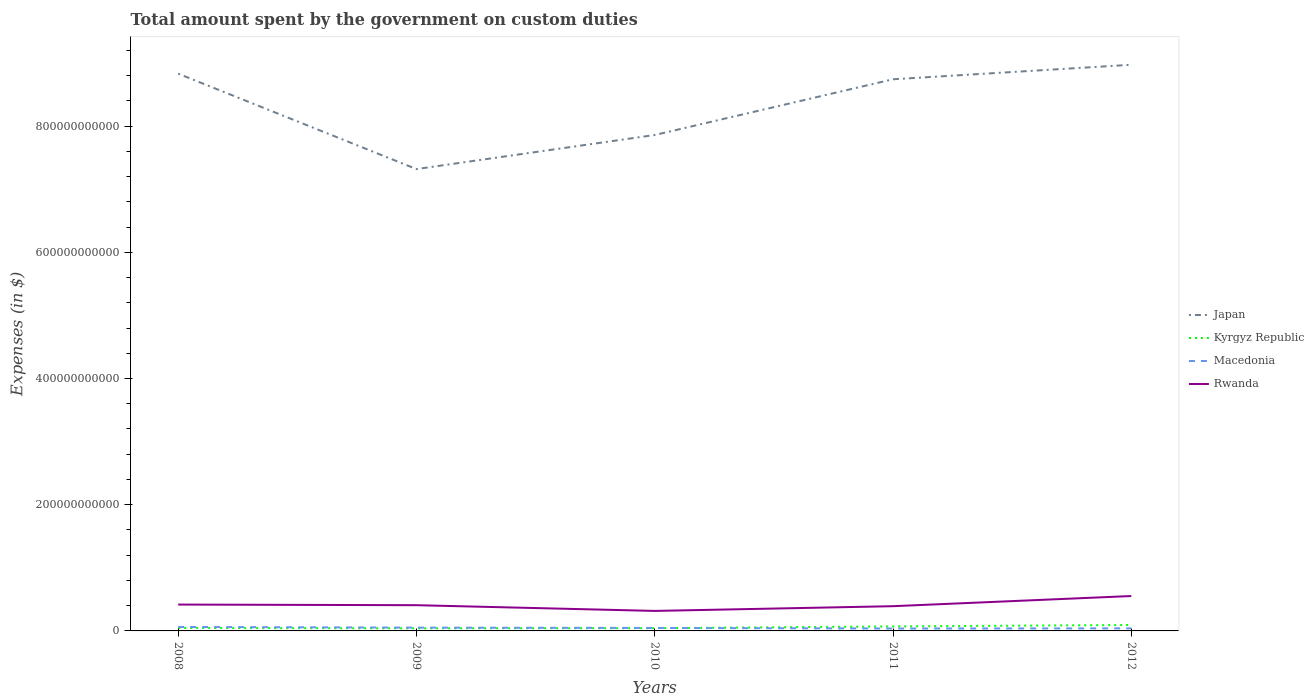How many different coloured lines are there?
Give a very brief answer. 4. Does the line corresponding to Japan intersect with the line corresponding to Kyrgyz Republic?
Your response must be concise. No. Is the number of lines equal to the number of legend labels?
Provide a short and direct response. Yes. Across all years, what is the maximum amount spent on custom duties by the government in Kyrgyz Republic?
Ensure brevity in your answer.  4.14e+09. In which year was the amount spent on custom duties by the government in Japan maximum?
Keep it short and to the point. 2009. What is the total amount spent on custom duties by the government in Rwanda in the graph?
Provide a short and direct response. 9.08e+09. What is the difference between the highest and the second highest amount spent on custom duties by the government in Japan?
Offer a very short reply. 1.65e+11. Is the amount spent on custom duties by the government in Japan strictly greater than the amount spent on custom duties by the government in Rwanda over the years?
Keep it short and to the point. No. How many lines are there?
Give a very brief answer. 4. What is the difference between two consecutive major ticks on the Y-axis?
Provide a short and direct response. 2.00e+11. Are the values on the major ticks of Y-axis written in scientific E-notation?
Provide a succinct answer. No. Does the graph contain any zero values?
Make the answer very short. No. How many legend labels are there?
Give a very brief answer. 4. How are the legend labels stacked?
Ensure brevity in your answer.  Vertical. What is the title of the graph?
Keep it short and to the point. Total amount spent by the government on custom duties. Does "Marshall Islands" appear as one of the legend labels in the graph?
Offer a terse response. No. What is the label or title of the Y-axis?
Your answer should be very brief. Expenses (in $). What is the Expenses (in $) of Japan in 2008?
Offer a terse response. 8.83e+11. What is the Expenses (in $) in Kyrgyz Republic in 2008?
Keep it short and to the point. 4.63e+09. What is the Expenses (in $) in Macedonia in 2008?
Your answer should be compact. 6.28e+09. What is the Expenses (in $) of Rwanda in 2008?
Keep it short and to the point. 4.18e+1. What is the Expenses (in $) in Japan in 2009?
Your answer should be compact. 7.32e+11. What is the Expenses (in $) in Kyrgyz Republic in 2009?
Give a very brief answer. 4.14e+09. What is the Expenses (in $) in Macedonia in 2009?
Provide a short and direct response. 5.23e+09. What is the Expenses (in $) in Rwanda in 2009?
Make the answer very short. 4.08e+1. What is the Expenses (in $) of Japan in 2010?
Keep it short and to the point. 7.86e+11. What is the Expenses (in $) of Kyrgyz Republic in 2010?
Offer a very short reply. 4.34e+09. What is the Expenses (in $) in Macedonia in 2010?
Offer a terse response. 4.71e+09. What is the Expenses (in $) in Rwanda in 2010?
Make the answer very short. 3.17e+1. What is the Expenses (in $) in Japan in 2011?
Your answer should be very brief. 8.74e+11. What is the Expenses (in $) of Kyrgyz Republic in 2011?
Provide a succinct answer. 7.15e+09. What is the Expenses (in $) of Macedonia in 2011?
Your answer should be compact. 3.78e+09. What is the Expenses (in $) of Rwanda in 2011?
Keep it short and to the point. 3.92e+1. What is the Expenses (in $) in Japan in 2012?
Provide a succinct answer. 8.97e+11. What is the Expenses (in $) in Kyrgyz Republic in 2012?
Make the answer very short. 9.43e+09. What is the Expenses (in $) in Macedonia in 2012?
Offer a very short reply. 4.07e+09. What is the Expenses (in $) in Rwanda in 2012?
Offer a terse response. 5.53e+1. Across all years, what is the maximum Expenses (in $) in Japan?
Offer a terse response. 8.97e+11. Across all years, what is the maximum Expenses (in $) in Kyrgyz Republic?
Make the answer very short. 9.43e+09. Across all years, what is the maximum Expenses (in $) in Macedonia?
Provide a short and direct response. 6.28e+09. Across all years, what is the maximum Expenses (in $) of Rwanda?
Provide a succinct answer. 5.53e+1. Across all years, what is the minimum Expenses (in $) of Japan?
Your answer should be very brief. 7.32e+11. Across all years, what is the minimum Expenses (in $) of Kyrgyz Republic?
Offer a very short reply. 4.14e+09. Across all years, what is the minimum Expenses (in $) in Macedonia?
Make the answer very short. 3.78e+09. Across all years, what is the minimum Expenses (in $) of Rwanda?
Give a very brief answer. 3.17e+1. What is the total Expenses (in $) of Japan in the graph?
Make the answer very short. 4.17e+12. What is the total Expenses (in $) of Kyrgyz Republic in the graph?
Your answer should be compact. 2.97e+1. What is the total Expenses (in $) in Macedonia in the graph?
Keep it short and to the point. 2.41e+1. What is the total Expenses (in $) of Rwanda in the graph?
Give a very brief answer. 2.09e+11. What is the difference between the Expenses (in $) of Japan in 2008 and that in 2009?
Your response must be concise. 1.51e+11. What is the difference between the Expenses (in $) in Kyrgyz Republic in 2008 and that in 2009?
Provide a short and direct response. 4.96e+08. What is the difference between the Expenses (in $) in Macedonia in 2008 and that in 2009?
Make the answer very short. 1.05e+09. What is the difference between the Expenses (in $) in Rwanda in 2008 and that in 2009?
Provide a short and direct response. 9.98e+08. What is the difference between the Expenses (in $) of Japan in 2008 and that in 2010?
Make the answer very short. 9.72e+1. What is the difference between the Expenses (in $) of Kyrgyz Republic in 2008 and that in 2010?
Ensure brevity in your answer.  2.90e+08. What is the difference between the Expenses (in $) in Macedonia in 2008 and that in 2010?
Provide a short and direct response. 1.56e+09. What is the difference between the Expenses (in $) in Rwanda in 2008 and that in 2010?
Ensure brevity in your answer.  1.01e+1. What is the difference between the Expenses (in $) of Japan in 2008 and that in 2011?
Your response must be concise. 8.90e+09. What is the difference between the Expenses (in $) in Kyrgyz Republic in 2008 and that in 2011?
Your response must be concise. -2.52e+09. What is the difference between the Expenses (in $) in Macedonia in 2008 and that in 2011?
Keep it short and to the point. 2.50e+09. What is the difference between the Expenses (in $) in Rwanda in 2008 and that in 2011?
Provide a short and direct response. 2.58e+09. What is the difference between the Expenses (in $) of Japan in 2008 and that in 2012?
Provide a succinct answer. -1.41e+1. What is the difference between the Expenses (in $) in Kyrgyz Republic in 2008 and that in 2012?
Your response must be concise. -4.80e+09. What is the difference between the Expenses (in $) of Macedonia in 2008 and that in 2012?
Give a very brief answer. 2.21e+09. What is the difference between the Expenses (in $) in Rwanda in 2008 and that in 2012?
Provide a succinct answer. -1.35e+1. What is the difference between the Expenses (in $) of Japan in 2009 and that in 2010?
Ensure brevity in your answer.  -5.40e+1. What is the difference between the Expenses (in $) in Kyrgyz Republic in 2009 and that in 2010?
Your answer should be very brief. -2.06e+08. What is the difference between the Expenses (in $) of Macedonia in 2009 and that in 2010?
Ensure brevity in your answer.  5.17e+08. What is the difference between the Expenses (in $) in Rwanda in 2009 and that in 2010?
Provide a short and direct response. 9.08e+09. What is the difference between the Expenses (in $) in Japan in 2009 and that in 2011?
Make the answer very short. -1.42e+11. What is the difference between the Expenses (in $) in Kyrgyz Republic in 2009 and that in 2011?
Keep it short and to the point. -3.01e+09. What is the difference between the Expenses (in $) in Macedonia in 2009 and that in 2011?
Ensure brevity in your answer.  1.45e+09. What is the difference between the Expenses (in $) in Rwanda in 2009 and that in 2011?
Offer a terse response. 1.58e+09. What is the difference between the Expenses (in $) in Japan in 2009 and that in 2012?
Keep it short and to the point. -1.65e+11. What is the difference between the Expenses (in $) of Kyrgyz Republic in 2009 and that in 2012?
Ensure brevity in your answer.  -5.29e+09. What is the difference between the Expenses (in $) of Macedonia in 2009 and that in 2012?
Keep it short and to the point. 1.16e+09. What is the difference between the Expenses (in $) in Rwanda in 2009 and that in 2012?
Your answer should be very brief. -1.45e+1. What is the difference between the Expenses (in $) in Japan in 2010 and that in 2011?
Offer a very short reply. -8.83e+1. What is the difference between the Expenses (in $) of Kyrgyz Republic in 2010 and that in 2011?
Your answer should be compact. -2.81e+09. What is the difference between the Expenses (in $) of Macedonia in 2010 and that in 2011?
Your answer should be compact. 9.33e+08. What is the difference between the Expenses (in $) of Rwanda in 2010 and that in 2011?
Provide a succinct answer. -7.50e+09. What is the difference between the Expenses (in $) in Japan in 2010 and that in 2012?
Keep it short and to the point. -1.11e+11. What is the difference between the Expenses (in $) in Kyrgyz Republic in 2010 and that in 2012?
Offer a terse response. -5.09e+09. What is the difference between the Expenses (in $) in Macedonia in 2010 and that in 2012?
Give a very brief answer. 6.45e+08. What is the difference between the Expenses (in $) in Rwanda in 2010 and that in 2012?
Make the answer very short. -2.36e+1. What is the difference between the Expenses (in $) in Japan in 2011 and that in 2012?
Ensure brevity in your answer.  -2.30e+1. What is the difference between the Expenses (in $) of Kyrgyz Republic in 2011 and that in 2012?
Your answer should be very brief. -2.28e+09. What is the difference between the Expenses (in $) in Macedonia in 2011 and that in 2012?
Your answer should be compact. -2.88e+08. What is the difference between the Expenses (in $) in Rwanda in 2011 and that in 2012?
Make the answer very short. -1.61e+1. What is the difference between the Expenses (in $) in Japan in 2008 and the Expenses (in $) in Kyrgyz Republic in 2009?
Offer a terse response. 8.79e+11. What is the difference between the Expenses (in $) of Japan in 2008 and the Expenses (in $) of Macedonia in 2009?
Your response must be concise. 8.78e+11. What is the difference between the Expenses (in $) in Japan in 2008 and the Expenses (in $) in Rwanda in 2009?
Your response must be concise. 8.42e+11. What is the difference between the Expenses (in $) in Kyrgyz Republic in 2008 and the Expenses (in $) in Macedonia in 2009?
Your answer should be very brief. -5.97e+08. What is the difference between the Expenses (in $) of Kyrgyz Republic in 2008 and the Expenses (in $) of Rwanda in 2009?
Ensure brevity in your answer.  -3.61e+1. What is the difference between the Expenses (in $) in Macedonia in 2008 and the Expenses (in $) in Rwanda in 2009?
Provide a succinct answer. -3.45e+1. What is the difference between the Expenses (in $) of Japan in 2008 and the Expenses (in $) of Kyrgyz Republic in 2010?
Provide a succinct answer. 8.79e+11. What is the difference between the Expenses (in $) in Japan in 2008 and the Expenses (in $) in Macedonia in 2010?
Your response must be concise. 8.78e+11. What is the difference between the Expenses (in $) of Japan in 2008 and the Expenses (in $) of Rwanda in 2010?
Provide a succinct answer. 8.51e+11. What is the difference between the Expenses (in $) of Kyrgyz Republic in 2008 and the Expenses (in $) of Macedonia in 2010?
Offer a terse response. -8.02e+07. What is the difference between the Expenses (in $) in Kyrgyz Republic in 2008 and the Expenses (in $) in Rwanda in 2010?
Provide a succinct answer. -2.71e+1. What is the difference between the Expenses (in $) in Macedonia in 2008 and the Expenses (in $) in Rwanda in 2010?
Your response must be concise. -2.54e+1. What is the difference between the Expenses (in $) in Japan in 2008 and the Expenses (in $) in Kyrgyz Republic in 2011?
Provide a succinct answer. 8.76e+11. What is the difference between the Expenses (in $) of Japan in 2008 and the Expenses (in $) of Macedonia in 2011?
Give a very brief answer. 8.79e+11. What is the difference between the Expenses (in $) of Japan in 2008 and the Expenses (in $) of Rwanda in 2011?
Keep it short and to the point. 8.44e+11. What is the difference between the Expenses (in $) in Kyrgyz Republic in 2008 and the Expenses (in $) in Macedonia in 2011?
Keep it short and to the point. 8.53e+08. What is the difference between the Expenses (in $) of Kyrgyz Republic in 2008 and the Expenses (in $) of Rwanda in 2011?
Provide a short and direct response. -3.46e+1. What is the difference between the Expenses (in $) of Macedonia in 2008 and the Expenses (in $) of Rwanda in 2011?
Your response must be concise. -3.29e+1. What is the difference between the Expenses (in $) of Japan in 2008 and the Expenses (in $) of Kyrgyz Republic in 2012?
Your answer should be very brief. 8.74e+11. What is the difference between the Expenses (in $) of Japan in 2008 and the Expenses (in $) of Macedonia in 2012?
Ensure brevity in your answer.  8.79e+11. What is the difference between the Expenses (in $) in Japan in 2008 and the Expenses (in $) in Rwanda in 2012?
Keep it short and to the point. 8.28e+11. What is the difference between the Expenses (in $) of Kyrgyz Republic in 2008 and the Expenses (in $) of Macedonia in 2012?
Give a very brief answer. 5.65e+08. What is the difference between the Expenses (in $) of Kyrgyz Republic in 2008 and the Expenses (in $) of Rwanda in 2012?
Your answer should be compact. -5.07e+1. What is the difference between the Expenses (in $) of Macedonia in 2008 and the Expenses (in $) of Rwanda in 2012?
Offer a terse response. -4.90e+1. What is the difference between the Expenses (in $) of Japan in 2009 and the Expenses (in $) of Kyrgyz Republic in 2010?
Offer a very short reply. 7.28e+11. What is the difference between the Expenses (in $) in Japan in 2009 and the Expenses (in $) in Macedonia in 2010?
Give a very brief answer. 7.27e+11. What is the difference between the Expenses (in $) of Japan in 2009 and the Expenses (in $) of Rwanda in 2010?
Offer a terse response. 7.00e+11. What is the difference between the Expenses (in $) in Kyrgyz Republic in 2009 and the Expenses (in $) in Macedonia in 2010?
Ensure brevity in your answer.  -5.77e+08. What is the difference between the Expenses (in $) of Kyrgyz Republic in 2009 and the Expenses (in $) of Rwanda in 2010?
Make the answer very short. -2.76e+1. What is the difference between the Expenses (in $) of Macedonia in 2009 and the Expenses (in $) of Rwanda in 2010?
Offer a very short reply. -2.65e+1. What is the difference between the Expenses (in $) of Japan in 2009 and the Expenses (in $) of Kyrgyz Republic in 2011?
Your answer should be compact. 7.25e+11. What is the difference between the Expenses (in $) of Japan in 2009 and the Expenses (in $) of Macedonia in 2011?
Your response must be concise. 7.28e+11. What is the difference between the Expenses (in $) of Japan in 2009 and the Expenses (in $) of Rwanda in 2011?
Make the answer very short. 6.93e+11. What is the difference between the Expenses (in $) of Kyrgyz Republic in 2009 and the Expenses (in $) of Macedonia in 2011?
Your answer should be very brief. 3.56e+08. What is the difference between the Expenses (in $) of Kyrgyz Republic in 2009 and the Expenses (in $) of Rwanda in 2011?
Your answer should be compact. -3.51e+1. What is the difference between the Expenses (in $) in Macedonia in 2009 and the Expenses (in $) in Rwanda in 2011?
Your answer should be compact. -3.40e+1. What is the difference between the Expenses (in $) in Japan in 2009 and the Expenses (in $) in Kyrgyz Republic in 2012?
Make the answer very short. 7.22e+11. What is the difference between the Expenses (in $) of Japan in 2009 and the Expenses (in $) of Macedonia in 2012?
Ensure brevity in your answer.  7.28e+11. What is the difference between the Expenses (in $) of Japan in 2009 and the Expenses (in $) of Rwanda in 2012?
Give a very brief answer. 6.77e+11. What is the difference between the Expenses (in $) in Kyrgyz Republic in 2009 and the Expenses (in $) in Macedonia in 2012?
Your answer should be very brief. 6.84e+07. What is the difference between the Expenses (in $) in Kyrgyz Republic in 2009 and the Expenses (in $) in Rwanda in 2012?
Provide a succinct answer. -5.12e+1. What is the difference between the Expenses (in $) in Macedonia in 2009 and the Expenses (in $) in Rwanda in 2012?
Give a very brief answer. -5.01e+1. What is the difference between the Expenses (in $) in Japan in 2010 and the Expenses (in $) in Kyrgyz Republic in 2011?
Provide a succinct answer. 7.79e+11. What is the difference between the Expenses (in $) in Japan in 2010 and the Expenses (in $) in Macedonia in 2011?
Provide a succinct answer. 7.82e+11. What is the difference between the Expenses (in $) in Japan in 2010 and the Expenses (in $) in Rwanda in 2011?
Offer a very short reply. 7.47e+11. What is the difference between the Expenses (in $) of Kyrgyz Republic in 2010 and the Expenses (in $) of Macedonia in 2011?
Your answer should be compact. 5.63e+08. What is the difference between the Expenses (in $) in Kyrgyz Republic in 2010 and the Expenses (in $) in Rwanda in 2011?
Provide a succinct answer. -3.49e+1. What is the difference between the Expenses (in $) of Macedonia in 2010 and the Expenses (in $) of Rwanda in 2011?
Provide a short and direct response. -3.45e+1. What is the difference between the Expenses (in $) of Japan in 2010 and the Expenses (in $) of Kyrgyz Republic in 2012?
Your answer should be compact. 7.76e+11. What is the difference between the Expenses (in $) of Japan in 2010 and the Expenses (in $) of Macedonia in 2012?
Your answer should be very brief. 7.82e+11. What is the difference between the Expenses (in $) of Japan in 2010 and the Expenses (in $) of Rwanda in 2012?
Keep it short and to the point. 7.31e+11. What is the difference between the Expenses (in $) in Kyrgyz Republic in 2010 and the Expenses (in $) in Macedonia in 2012?
Your answer should be very brief. 2.75e+08. What is the difference between the Expenses (in $) in Kyrgyz Republic in 2010 and the Expenses (in $) in Rwanda in 2012?
Provide a short and direct response. -5.10e+1. What is the difference between the Expenses (in $) of Macedonia in 2010 and the Expenses (in $) of Rwanda in 2012?
Provide a succinct answer. -5.06e+1. What is the difference between the Expenses (in $) of Japan in 2011 and the Expenses (in $) of Kyrgyz Republic in 2012?
Provide a short and direct response. 8.65e+11. What is the difference between the Expenses (in $) in Japan in 2011 and the Expenses (in $) in Macedonia in 2012?
Keep it short and to the point. 8.70e+11. What is the difference between the Expenses (in $) of Japan in 2011 and the Expenses (in $) of Rwanda in 2012?
Keep it short and to the point. 8.19e+11. What is the difference between the Expenses (in $) of Kyrgyz Republic in 2011 and the Expenses (in $) of Macedonia in 2012?
Give a very brief answer. 3.08e+09. What is the difference between the Expenses (in $) in Kyrgyz Republic in 2011 and the Expenses (in $) in Rwanda in 2012?
Keep it short and to the point. -4.82e+1. What is the difference between the Expenses (in $) of Macedonia in 2011 and the Expenses (in $) of Rwanda in 2012?
Give a very brief answer. -5.15e+1. What is the average Expenses (in $) of Japan per year?
Provide a short and direct response. 8.34e+11. What is the average Expenses (in $) of Kyrgyz Republic per year?
Your answer should be compact. 5.94e+09. What is the average Expenses (in $) of Macedonia per year?
Offer a terse response. 4.81e+09. What is the average Expenses (in $) of Rwanda per year?
Offer a terse response. 4.18e+1. In the year 2008, what is the difference between the Expenses (in $) in Japan and Expenses (in $) in Kyrgyz Republic?
Provide a succinct answer. 8.78e+11. In the year 2008, what is the difference between the Expenses (in $) in Japan and Expenses (in $) in Macedonia?
Make the answer very short. 8.77e+11. In the year 2008, what is the difference between the Expenses (in $) in Japan and Expenses (in $) in Rwanda?
Make the answer very short. 8.41e+11. In the year 2008, what is the difference between the Expenses (in $) of Kyrgyz Republic and Expenses (in $) of Macedonia?
Keep it short and to the point. -1.64e+09. In the year 2008, what is the difference between the Expenses (in $) of Kyrgyz Republic and Expenses (in $) of Rwanda?
Offer a terse response. -3.71e+1. In the year 2008, what is the difference between the Expenses (in $) of Macedonia and Expenses (in $) of Rwanda?
Offer a terse response. -3.55e+1. In the year 2009, what is the difference between the Expenses (in $) in Japan and Expenses (in $) in Kyrgyz Republic?
Offer a very short reply. 7.28e+11. In the year 2009, what is the difference between the Expenses (in $) in Japan and Expenses (in $) in Macedonia?
Your answer should be compact. 7.27e+11. In the year 2009, what is the difference between the Expenses (in $) of Japan and Expenses (in $) of Rwanda?
Provide a short and direct response. 6.91e+11. In the year 2009, what is the difference between the Expenses (in $) in Kyrgyz Republic and Expenses (in $) in Macedonia?
Ensure brevity in your answer.  -1.09e+09. In the year 2009, what is the difference between the Expenses (in $) of Kyrgyz Republic and Expenses (in $) of Rwanda?
Offer a very short reply. -3.66e+1. In the year 2009, what is the difference between the Expenses (in $) of Macedonia and Expenses (in $) of Rwanda?
Keep it short and to the point. -3.56e+1. In the year 2010, what is the difference between the Expenses (in $) in Japan and Expenses (in $) in Kyrgyz Republic?
Make the answer very short. 7.82e+11. In the year 2010, what is the difference between the Expenses (in $) of Japan and Expenses (in $) of Macedonia?
Your answer should be very brief. 7.81e+11. In the year 2010, what is the difference between the Expenses (in $) of Japan and Expenses (in $) of Rwanda?
Give a very brief answer. 7.54e+11. In the year 2010, what is the difference between the Expenses (in $) in Kyrgyz Republic and Expenses (in $) in Macedonia?
Provide a succinct answer. -3.70e+08. In the year 2010, what is the difference between the Expenses (in $) in Kyrgyz Republic and Expenses (in $) in Rwanda?
Keep it short and to the point. -2.74e+1. In the year 2010, what is the difference between the Expenses (in $) of Macedonia and Expenses (in $) of Rwanda?
Give a very brief answer. -2.70e+1. In the year 2011, what is the difference between the Expenses (in $) in Japan and Expenses (in $) in Kyrgyz Republic?
Keep it short and to the point. 8.67e+11. In the year 2011, what is the difference between the Expenses (in $) in Japan and Expenses (in $) in Macedonia?
Make the answer very short. 8.70e+11. In the year 2011, what is the difference between the Expenses (in $) of Japan and Expenses (in $) of Rwanda?
Keep it short and to the point. 8.35e+11. In the year 2011, what is the difference between the Expenses (in $) of Kyrgyz Republic and Expenses (in $) of Macedonia?
Make the answer very short. 3.37e+09. In the year 2011, what is the difference between the Expenses (in $) of Kyrgyz Republic and Expenses (in $) of Rwanda?
Offer a very short reply. -3.21e+1. In the year 2011, what is the difference between the Expenses (in $) in Macedonia and Expenses (in $) in Rwanda?
Offer a very short reply. -3.54e+1. In the year 2012, what is the difference between the Expenses (in $) of Japan and Expenses (in $) of Kyrgyz Republic?
Your response must be concise. 8.88e+11. In the year 2012, what is the difference between the Expenses (in $) in Japan and Expenses (in $) in Macedonia?
Give a very brief answer. 8.93e+11. In the year 2012, what is the difference between the Expenses (in $) in Japan and Expenses (in $) in Rwanda?
Provide a short and direct response. 8.42e+11. In the year 2012, what is the difference between the Expenses (in $) in Kyrgyz Republic and Expenses (in $) in Macedonia?
Make the answer very short. 5.36e+09. In the year 2012, what is the difference between the Expenses (in $) in Kyrgyz Republic and Expenses (in $) in Rwanda?
Make the answer very short. -4.59e+1. In the year 2012, what is the difference between the Expenses (in $) in Macedonia and Expenses (in $) in Rwanda?
Your answer should be very brief. -5.12e+1. What is the ratio of the Expenses (in $) of Japan in 2008 to that in 2009?
Your response must be concise. 1.21. What is the ratio of the Expenses (in $) of Kyrgyz Republic in 2008 to that in 2009?
Keep it short and to the point. 1.12. What is the ratio of the Expenses (in $) of Macedonia in 2008 to that in 2009?
Provide a succinct answer. 1.2. What is the ratio of the Expenses (in $) of Rwanda in 2008 to that in 2009?
Offer a very short reply. 1.02. What is the ratio of the Expenses (in $) of Japan in 2008 to that in 2010?
Provide a short and direct response. 1.12. What is the ratio of the Expenses (in $) in Kyrgyz Republic in 2008 to that in 2010?
Make the answer very short. 1.07. What is the ratio of the Expenses (in $) in Macedonia in 2008 to that in 2010?
Provide a short and direct response. 1.33. What is the ratio of the Expenses (in $) in Rwanda in 2008 to that in 2010?
Keep it short and to the point. 1.32. What is the ratio of the Expenses (in $) in Japan in 2008 to that in 2011?
Make the answer very short. 1.01. What is the ratio of the Expenses (in $) in Kyrgyz Republic in 2008 to that in 2011?
Ensure brevity in your answer.  0.65. What is the ratio of the Expenses (in $) of Macedonia in 2008 to that in 2011?
Offer a very short reply. 1.66. What is the ratio of the Expenses (in $) of Rwanda in 2008 to that in 2011?
Offer a terse response. 1.07. What is the ratio of the Expenses (in $) of Japan in 2008 to that in 2012?
Your answer should be very brief. 0.98. What is the ratio of the Expenses (in $) in Kyrgyz Republic in 2008 to that in 2012?
Provide a short and direct response. 0.49. What is the ratio of the Expenses (in $) of Macedonia in 2008 to that in 2012?
Your answer should be very brief. 1.54. What is the ratio of the Expenses (in $) of Rwanda in 2008 to that in 2012?
Offer a terse response. 0.76. What is the ratio of the Expenses (in $) in Japan in 2009 to that in 2010?
Provide a short and direct response. 0.93. What is the ratio of the Expenses (in $) in Kyrgyz Republic in 2009 to that in 2010?
Your answer should be compact. 0.95. What is the ratio of the Expenses (in $) in Macedonia in 2009 to that in 2010?
Keep it short and to the point. 1.11. What is the ratio of the Expenses (in $) of Rwanda in 2009 to that in 2010?
Provide a short and direct response. 1.29. What is the ratio of the Expenses (in $) in Japan in 2009 to that in 2011?
Offer a very short reply. 0.84. What is the ratio of the Expenses (in $) of Kyrgyz Republic in 2009 to that in 2011?
Your answer should be very brief. 0.58. What is the ratio of the Expenses (in $) in Macedonia in 2009 to that in 2011?
Offer a very short reply. 1.38. What is the ratio of the Expenses (in $) in Rwanda in 2009 to that in 2011?
Provide a succinct answer. 1.04. What is the ratio of the Expenses (in $) in Japan in 2009 to that in 2012?
Provide a short and direct response. 0.82. What is the ratio of the Expenses (in $) of Kyrgyz Republic in 2009 to that in 2012?
Provide a short and direct response. 0.44. What is the ratio of the Expenses (in $) in Macedonia in 2009 to that in 2012?
Keep it short and to the point. 1.29. What is the ratio of the Expenses (in $) in Rwanda in 2009 to that in 2012?
Your response must be concise. 0.74. What is the ratio of the Expenses (in $) in Japan in 2010 to that in 2011?
Ensure brevity in your answer.  0.9. What is the ratio of the Expenses (in $) in Kyrgyz Republic in 2010 to that in 2011?
Keep it short and to the point. 0.61. What is the ratio of the Expenses (in $) in Macedonia in 2010 to that in 2011?
Keep it short and to the point. 1.25. What is the ratio of the Expenses (in $) of Rwanda in 2010 to that in 2011?
Make the answer very short. 0.81. What is the ratio of the Expenses (in $) in Japan in 2010 to that in 2012?
Ensure brevity in your answer.  0.88. What is the ratio of the Expenses (in $) in Kyrgyz Republic in 2010 to that in 2012?
Provide a succinct answer. 0.46. What is the ratio of the Expenses (in $) of Macedonia in 2010 to that in 2012?
Your response must be concise. 1.16. What is the ratio of the Expenses (in $) of Rwanda in 2010 to that in 2012?
Ensure brevity in your answer.  0.57. What is the ratio of the Expenses (in $) of Japan in 2011 to that in 2012?
Keep it short and to the point. 0.97. What is the ratio of the Expenses (in $) of Kyrgyz Republic in 2011 to that in 2012?
Your answer should be very brief. 0.76. What is the ratio of the Expenses (in $) in Macedonia in 2011 to that in 2012?
Your answer should be compact. 0.93. What is the ratio of the Expenses (in $) of Rwanda in 2011 to that in 2012?
Your response must be concise. 0.71. What is the difference between the highest and the second highest Expenses (in $) of Japan?
Your response must be concise. 1.41e+1. What is the difference between the highest and the second highest Expenses (in $) in Kyrgyz Republic?
Your answer should be very brief. 2.28e+09. What is the difference between the highest and the second highest Expenses (in $) in Macedonia?
Offer a very short reply. 1.05e+09. What is the difference between the highest and the second highest Expenses (in $) in Rwanda?
Provide a short and direct response. 1.35e+1. What is the difference between the highest and the lowest Expenses (in $) in Japan?
Provide a short and direct response. 1.65e+11. What is the difference between the highest and the lowest Expenses (in $) of Kyrgyz Republic?
Ensure brevity in your answer.  5.29e+09. What is the difference between the highest and the lowest Expenses (in $) in Macedonia?
Provide a succinct answer. 2.50e+09. What is the difference between the highest and the lowest Expenses (in $) of Rwanda?
Your answer should be very brief. 2.36e+1. 